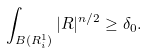Convert formula to latex. <formula><loc_0><loc_0><loc_500><loc_500>\int _ { B ( R _ { i } ^ { 1 } ) } | R | ^ { n / 2 } \geq \delta _ { 0 } .</formula> 